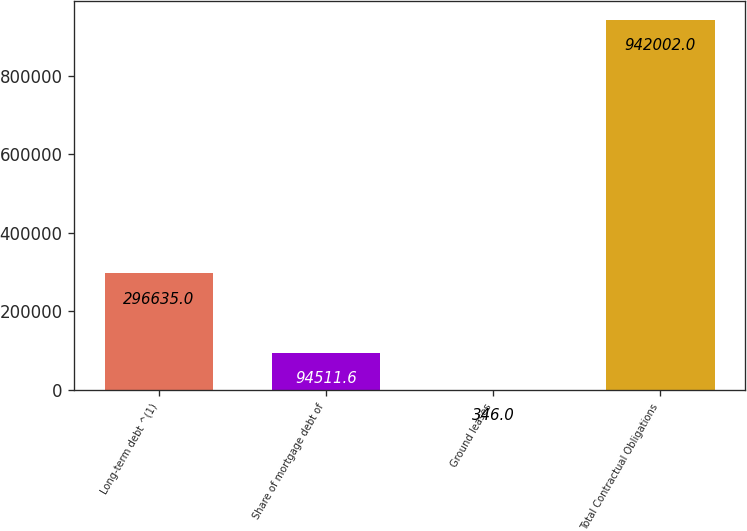Convert chart to OTSL. <chart><loc_0><loc_0><loc_500><loc_500><bar_chart><fcel>Long-term debt ^(1)<fcel>Share of mortgage debt of<fcel>Ground leases<fcel>Total Contractual Obligations<nl><fcel>296635<fcel>94511.6<fcel>346<fcel>942002<nl></chart> 